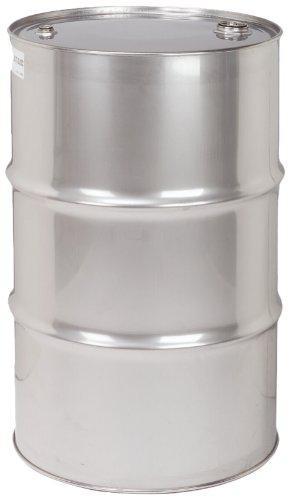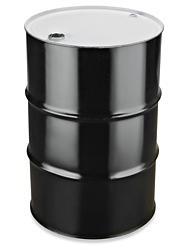The first image is the image on the left, the second image is the image on the right. Considering the images on both sides, is "All barrels shown are the same color, but one image contains a single barrel, while the other contains at least five." valid? Answer yes or no. No. The first image is the image on the left, the second image is the image on the right. Given the left and right images, does the statement "There are at least four cans." hold true? Answer yes or no. No. 